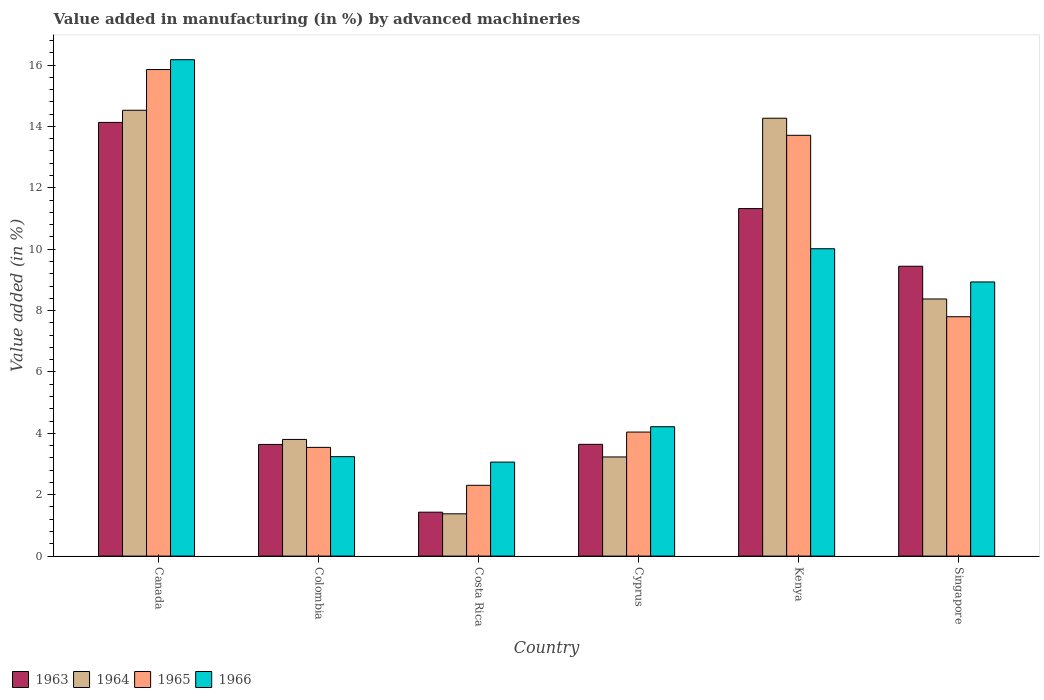How many different coloured bars are there?
Your answer should be very brief. 4. How many groups of bars are there?
Offer a very short reply. 6. Are the number of bars on each tick of the X-axis equal?
Ensure brevity in your answer.  Yes. How many bars are there on the 1st tick from the right?
Provide a short and direct response. 4. In how many cases, is the number of bars for a given country not equal to the number of legend labels?
Offer a very short reply. 0. What is the percentage of value added in manufacturing by advanced machineries in 1966 in Cyprus?
Make the answer very short. 4.22. Across all countries, what is the maximum percentage of value added in manufacturing by advanced machineries in 1966?
Offer a terse response. 16.17. Across all countries, what is the minimum percentage of value added in manufacturing by advanced machineries in 1965?
Keep it short and to the point. 2.31. What is the total percentage of value added in manufacturing by advanced machineries in 1966 in the graph?
Your response must be concise. 45.64. What is the difference between the percentage of value added in manufacturing by advanced machineries in 1966 in Canada and that in Kenya?
Offer a very short reply. 6.16. What is the difference between the percentage of value added in manufacturing by advanced machineries in 1964 in Cyprus and the percentage of value added in manufacturing by advanced machineries in 1965 in Costa Rica?
Give a very brief answer. 0.92. What is the average percentage of value added in manufacturing by advanced machineries in 1964 per country?
Offer a terse response. 7.6. What is the difference between the percentage of value added in manufacturing by advanced machineries of/in 1964 and percentage of value added in manufacturing by advanced machineries of/in 1963 in Kenya?
Provide a succinct answer. 2.94. In how many countries, is the percentage of value added in manufacturing by advanced machineries in 1965 greater than 14.4 %?
Keep it short and to the point. 1. What is the ratio of the percentage of value added in manufacturing by advanced machineries in 1966 in Kenya to that in Singapore?
Offer a very short reply. 1.12. Is the difference between the percentage of value added in manufacturing by advanced machineries in 1964 in Canada and Colombia greater than the difference between the percentage of value added in manufacturing by advanced machineries in 1963 in Canada and Colombia?
Your answer should be compact. Yes. What is the difference between the highest and the second highest percentage of value added in manufacturing by advanced machineries in 1965?
Make the answer very short. -5.91. What is the difference between the highest and the lowest percentage of value added in manufacturing by advanced machineries in 1966?
Ensure brevity in your answer.  13.11. In how many countries, is the percentage of value added in manufacturing by advanced machineries in 1964 greater than the average percentage of value added in manufacturing by advanced machineries in 1964 taken over all countries?
Give a very brief answer. 3. Is the sum of the percentage of value added in manufacturing by advanced machineries in 1966 in Canada and Costa Rica greater than the maximum percentage of value added in manufacturing by advanced machineries in 1963 across all countries?
Give a very brief answer. Yes. What does the 1st bar from the left in Singapore represents?
Provide a succinct answer. 1963. What does the 1st bar from the right in Kenya represents?
Your answer should be very brief. 1966. How many bars are there?
Offer a terse response. 24. Are the values on the major ticks of Y-axis written in scientific E-notation?
Give a very brief answer. No. Does the graph contain any zero values?
Your answer should be very brief. No. How are the legend labels stacked?
Provide a succinct answer. Horizontal. What is the title of the graph?
Make the answer very short. Value added in manufacturing (in %) by advanced machineries. What is the label or title of the X-axis?
Offer a very short reply. Country. What is the label or title of the Y-axis?
Your answer should be compact. Value added (in %). What is the Value added (in %) in 1963 in Canada?
Offer a very short reply. 14.13. What is the Value added (in %) in 1964 in Canada?
Offer a very short reply. 14.53. What is the Value added (in %) in 1965 in Canada?
Make the answer very short. 15.85. What is the Value added (in %) of 1966 in Canada?
Make the answer very short. 16.17. What is the Value added (in %) of 1963 in Colombia?
Your answer should be compact. 3.64. What is the Value added (in %) of 1964 in Colombia?
Keep it short and to the point. 3.8. What is the Value added (in %) in 1965 in Colombia?
Provide a succinct answer. 3.54. What is the Value added (in %) in 1966 in Colombia?
Give a very brief answer. 3.24. What is the Value added (in %) of 1963 in Costa Rica?
Your answer should be very brief. 1.43. What is the Value added (in %) in 1964 in Costa Rica?
Ensure brevity in your answer.  1.38. What is the Value added (in %) in 1965 in Costa Rica?
Offer a very short reply. 2.31. What is the Value added (in %) of 1966 in Costa Rica?
Your answer should be very brief. 3.06. What is the Value added (in %) of 1963 in Cyprus?
Provide a short and direct response. 3.64. What is the Value added (in %) of 1964 in Cyprus?
Keep it short and to the point. 3.23. What is the Value added (in %) in 1965 in Cyprus?
Your response must be concise. 4.04. What is the Value added (in %) in 1966 in Cyprus?
Give a very brief answer. 4.22. What is the Value added (in %) in 1963 in Kenya?
Provide a succinct answer. 11.32. What is the Value added (in %) in 1964 in Kenya?
Your answer should be compact. 14.27. What is the Value added (in %) of 1965 in Kenya?
Provide a short and direct response. 13.71. What is the Value added (in %) of 1966 in Kenya?
Your answer should be very brief. 10.01. What is the Value added (in %) of 1963 in Singapore?
Ensure brevity in your answer.  9.44. What is the Value added (in %) in 1964 in Singapore?
Your response must be concise. 8.38. What is the Value added (in %) of 1965 in Singapore?
Your response must be concise. 7.8. What is the Value added (in %) of 1966 in Singapore?
Ensure brevity in your answer.  8.93. Across all countries, what is the maximum Value added (in %) in 1963?
Ensure brevity in your answer.  14.13. Across all countries, what is the maximum Value added (in %) of 1964?
Give a very brief answer. 14.53. Across all countries, what is the maximum Value added (in %) in 1965?
Make the answer very short. 15.85. Across all countries, what is the maximum Value added (in %) of 1966?
Offer a very short reply. 16.17. Across all countries, what is the minimum Value added (in %) of 1963?
Provide a succinct answer. 1.43. Across all countries, what is the minimum Value added (in %) in 1964?
Provide a short and direct response. 1.38. Across all countries, what is the minimum Value added (in %) of 1965?
Give a very brief answer. 2.31. Across all countries, what is the minimum Value added (in %) in 1966?
Your response must be concise. 3.06. What is the total Value added (in %) of 1963 in the graph?
Keep it short and to the point. 43.61. What is the total Value added (in %) in 1964 in the graph?
Provide a succinct answer. 45.58. What is the total Value added (in %) of 1965 in the graph?
Provide a short and direct response. 47.25. What is the total Value added (in %) of 1966 in the graph?
Make the answer very short. 45.64. What is the difference between the Value added (in %) in 1963 in Canada and that in Colombia?
Offer a very short reply. 10.49. What is the difference between the Value added (in %) in 1964 in Canada and that in Colombia?
Offer a very short reply. 10.72. What is the difference between the Value added (in %) in 1965 in Canada and that in Colombia?
Provide a short and direct response. 12.31. What is the difference between the Value added (in %) of 1966 in Canada and that in Colombia?
Your response must be concise. 12.93. What is the difference between the Value added (in %) in 1963 in Canada and that in Costa Rica?
Give a very brief answer. 12.7. What is the difference between the Value added (in %) of 1964 in Canada and that in Costa Rica?
Provide a succinct answer. 13.15. What is the difference between the Value added (in %) in 1965 in Canada and that in Costa Rica?
Provide a short and direct response. 13.55. What is the difference between the Value added (in %) of 1966 in Canada and that in Costa Rica?
Offer a terse response. 13.11. What is the difference between the Value added (in %) in 1963 in Canada and that in Cyprus?
Give a very brief answer. 10.49. What is the difference between the Value added (in %) of 1964 in Canada and that in Cyprus?
Make the answer very short. 11.3. What is the difference between the Value added (in %) of 1965 in Canada and that in Cyprus?
Offer a terse response. 11.81. What is the difference between the Value added (in %) in 1966 in Canada and that in Cyprus?
Keep it short and to the point. 11.96. What is the difference between the Value added (in %) of 1963 in Canada and that in Kenya?
Offer a terse response. 2.81. What is the difference between the Value added (in %) of 1964 in Canada and that in Kenya?
Make the answer very short. 0.26. What is the difference between the Value added (in %) in 1965 in Canada and that in Kenya?
Offer a very short reply. 2.14. What is the difference between the Value added (in %) of 1966 in Canada and that in Kenya?
Provide a short and direct response. 6.16. What is the difference between the Value added (in %) of 1963 in Canada and that in Singapore?
Your response must be concise. 4.69. What is the difference between the Value added (in %) in 1964 in Canada and that in Singapore?
Ensure brevity in your answer.  6.15. What is the difference between the Value added (in %) in 1965 in Canada and that in Singapore?
Give a very brief answer. 8.05. What is the difference between the Value added (in %) in 1966 in Canada and that in Singapore?
Offer a terse response. 7.24. What is the difference between the Value added (in %) of 1963 in Colombia and that in Costa Rica?
Ensure brevity in your answer.  2.21. What is the difference between the Value added (in %) of 1964 in Colombia and that in Costa Rica?
Give a very brief answer. 2.42. What is the difference between the Value added (in %) of 1965 in Colombia and that in Costa Rica?
Offer a terse response. 1.24. What is the difference between the Value added (in %) of 1966 in Colombia and that in Costa Rica?
Your answer should be compact. 0.18. What is the difference between the Value added (in %) of 1963 in Colombia and that in Cyprus?
Offer a terse response. -0. What is the difference between the Value added (in %) in 1964 in Colombia and that in Cyprus?
Offer a very short reply. 0.57. What is the difference between the Value added (in %) of 1965 in Colombia and that in Cyprus?
Your answer should be very brief. -0.5. What is the difference between the Value added (in %) of 1966 in Colombia and that in Cyprus?
Keep it short and to the point. -0.97. What is the difference between the Value added (in %) in 1963 in Colombia and that in Kenya?
Your answer should be very brief. -7.69. What is the difference between the Value added (in %) in 1964 in Colombia and that in Kenya?
Keep it short and to the point. -10.47. What is the difference between the Value added (in %) in 1965 in Colombia and that in Kenya?
Your response must be concise. -10.17. What is the difference between the Value added (in %) in 1966 in Colombia and that in Kenya?
Provide a succinct answer. -6.77. What is the difference between the Value added (in %) of 1963 in Colombia and that in Singapore?
Make the answer very short. -5.81. What is the difference between the Value added (in %) in 1964 in Colombia and that in Singapore?
Your answer should be compact. -4.58. What is the difference between the Value added (in %) in 1965 in Colombia and that in Singapore?
Offer a terse response. -4.26. What is the difference between the Value added (in %) of 1966 in Colombia and that in Singapore?
Provide a short and direct response. -5.69. What is the difference between the Value added (in %) in 1963 in Costa Rica and that in Cyprus?
Your answer should be very brief. -2.21. What is the difference between the Value added (in %) of 1964 in Costa Rica and that in Cyprus?
Provide a succinct answer. -1.85. What is the difference between the Value added (in %) in 1965 in Costa Rica and that in Cyprus?
Your answer should be compact. -1.73. What is the difference between the Value added (in %) in 1966 in Costa Rica and that in Cyprus?
Give a very brief answer. -1.15. What is the difference between the Value added (in %) of 1963 in Costa Rica and that in Kenya?
Offer a very short reply. -9.89. What is the difference between the Value added (in %) of 1964 in Costa Rica and that in Kenya?
Give a very brief answer. -12.89. What is the difference between the Value added (in %) in 1965 in Costa Rica and that in Kenya?
Provide a succinct answer. -11.4. What is the difference between the Value added (in %) of 1966 in Costa Rica and that in Kenya?
Offer a very short reply. -6.95. What is the difference between the Value added (in %) in 1963 in Costa Rica and that in Singapore?
Offer a very short reply. -8.01. What is the difference between the Value added (in %) of 1964 in Costa Rica and that in Singapore?
Give a very brief answer. -7. What is the difference between the Value added (in %) in 1965 in Costa Rica and that in Singapore?
Your answer should be compact. -5.49. What is the difference between the Value added (in %) of 1966 in Costa Rica and that in Singapore?
Provide a succinct answer. -5.87. What is the difference between the Value added (in %) of 1963 in Cyprus and that in Kenya?
Your response must be concise. -7.68. What is the difference between the Value added (in %) in 1964 in Cyprus and that in Kenya?
Your answer should be compact. -11.04. What is the difference between the Value added (in %) in 1965 in Cyprus and that in Kenya?
Ensure brevity in your answer.  -9.67. What is the difference between the Value added (in %) in 1966 in Cyprus and that in Kenya?
Give a very brief answer. -5.8. What is the difference between the Value added (in %) of 1963 in Cyprus and that in Singapore?
Keep it short and to the point. -5.8. What is the difference between the Value added (in %) in 1964 in Cyprus and that in Singapore?
Your answer should be very brief. -5.15. What is the difference between the Value added (in %) of 1965 in Cyprus and that in Singapore?
Offer a very short reply. -3.76. What is the difference between the Value added (in %) in 1966 in Cyprus and that in Singapore?
Offer a very short reply. -4.72. What is the difference between the Value added (in %) of 1963 in Kenya and that in Singapore?
Give a very brief answer. 1.88. What is the difference between the Value added (in %) in 1964 in Kenya and that in Singapore?
Provide a succinct answer. 5.89. What is the difference between the Value added (in %) of 1965 in Kenya and that in Singapore?
Your response must be concise. 5.91. What is the difference between the Value added (in %) of 1966 in Kenya and that in Singapore?
Give a very brief answer. 1.08. What is the difference between the Value added (in %) of 1963 in Canada and the Value added (in %) of 1964 in Colombia?
Your answer should be very brief. 10.33. What is the difference between the Value added (in %) of 1963 in Canada and the Value added (in %) of 1965 in Colombia?
Provide a short and direct response. 10.59. What is the difference between the Value added (in %) of 1963 in Canada and the Value added (in %) of 1966 in Colombia?
Provide a succinct answer. 10.89. What is the difference between the Value added (in %) in 1964 in Canada and the Value added (in %) in 1965 in Colombia?
Keep it short and to the point. 10.98. What is the difference between the Value added (in %) of 1964 in Canada and the Value added (in %) of 1966 in Colombia?
Provide a succinct answer. 11.29. What is the difference between the Value added (in %) of 1965 in Canada and the Value added (in %) of 1966 in Colombia?
Keep it short and to the point. 12.61. What is the difference between the Value added (in %) in 1963 in Canada and the Value added (in %) in 1964 in Costa Rica?
Provide a succinct answer. 12.75. What is the difference between the Value added (in %) in 1963 in Canada and the Value added (in %) in 1965 in Costa Rica?
Offer a terse response. 11.82. What is the difference between the Value added (in %) of 1963 in Canada and the Value added (in %) of 1966 in Costa Rica?
Provide a short and direct response. 11.07. What is the difference between the Value added (in %) of 1964 in Canada and the Value added (in %) of 1965 in Costa Rica?
Your answer should be compact. 12.22. What is the difference between the Value added (in %) in 1964 in Canada and the Value added (in %) in 1966 in Costa Rica?
Provide a short and direct response. 11.46. What is the difference between the Value added (in %) of 1965 in Canada and the Value added (in %) of 1966 in Costa Rica?
Your answer should be compact. 12.79. What is the difference between the Value added (in %) of 1963 in Canada and the Value added (in %) of 1964 in Cyprus?
Offer a very short reply. 10.9. What is the difference between the Value added (in %) of 1963 in Canada and the Value added (in %) of 1965 in Cyprus?
Your answer should be very brief. 10.09. What is the difference between the Value added (in %) of 1963 in Canada and the Value added (in %) of 1966 in Cyprus?
Your answer should be compact. 9.92. What is the difference between the Value added (in %) of 1964 in Canada and the Value added (in %) of 1965 in Cyprus?
Your response must be concise. 10.49. What is the difference between the Value added (in %) of 1964 in Canada and the Value added (in %) of 1966 in Cyprus?
Your answer should be compact. 10.31. What is the difference between the Value added (in %) of 1965 in Canada and the Value added (in %) of 1966 in Cyprus?
Your answer should be compact. 11.64. What is the difference between the Value added (in %) in 1963 in Canada and the Value added (in %) in 1964 in Kenya?
Keep it short and to the point. -0.14. What is the difference between the Value added (in %) in 1963 in Canada and the Value added (in %) in 1965 in Kenya?
Provide a short and direct response. 0.42. What is the difference between the Value added (in %) of 1963 in Canada and the Value added (in %) of 1966 in Kenya?
Keep it short and to the point. 4.12. What is the difference between the Value added (in %) of 1964 in Canada and the Value added (in %) of 1965 in Kenya?
Ensure brevity in your answer.  0.82. What is the difference between the Value added (in %) in 1964 in Canada and the Value added (in %) in 1966 in Kenya?
Your answer should be compact. 4.51. What is the difference between the Value added (in %) in 1965 in Canada and the Value added (in %) in 1966 in Kenya?
Provide a short and direct response. 5.84. What is the difference between the Value added (in %) in 1963 in Canada and the Value added (in %) in 1964 in Singapore?
Provide a succinct answer. 5.75. What is the difference between the Value added (in %) of 1963 in Canada and the Value added (in %) of 1965 in Singapore?
Give a very brief answer. 6.33. What is the difference between the Value added (in %) in 1963 in Canada and the Value added (in %) in 1966 in Singapore?
Ensure brevity in your answer.  5.2. What is the difference between the Value added (in %) in 1964 in Canada and the Value added (in %) in 1965 in Singapore?
Make the answer very short. 6.73. What is the difference between the Value added (in %) in 1964 in Canada and the Value added (in %) in 1966 in Singapore?
Your answer should be compact. 5.59. What is the difference between the Value added (in %) in 1965 in Canada and the Value added (in %) in 1966 in Singapore?
Provide a short and direct response. 6.92. What is the difference between the Value added (in %) of 1963 in Colombia and the Value added (in %) of 1964 in Costa Rica?
Make the answer very short. 2.26. What is the difference between the Value added (in %) in 1963 in Colombia and the Value added (in %) in 1965 in Costa Rica?
Keep it short and to the point. 1.33. What is the difference between the Value added (in %) in 1963 in Colombia and the Value added (in %) in 1966 in Costa Rica?
Your answer should be compact. 0.57. What is the difference between the Value added (in %) of 1964 in Colombia and the Value added (in %) of 1965 in Costa Rica?
Give a very brief answer. 1.49. What is the difference between the Value added (in %) in 1964 in Colombia and the Value added (in %) in 1966 in Costa Rica?
Keep it short and to the point. 0.74. What is the difference between the Value added (in %) in 1965 in Colombia and the Value added (in %) in 1966 in Costa Rica?
Offer a terse response. 0.48. What is the difference between the Value added (in %) in 1963 in Colombia and the Value added (in %) in 1964 in Cyprus?
Make the answer very short. 0.41. What is the difference between the Value added (in %) in 1963 in Colombia and the Value added (in %) in 1965 in Cyprus?
Provide a succinct answer. -0.4. What is the difference between the Value added (in %) of 1963 in Colombia and the Value added (in %) of 1966 in Cyprus?
Give a very brief answer. -0.58. What is the difference between the Value added (in %) in 1964 in Colombia and the Value added (in %) in 1965 in Cyprus?
Offer a terse response. -0.24. What is the difference between the Value added (in %) in 1964 in Colombia and the Value added (in %) in 1966 in Cyprus?
Your response must be concise. -0.41. What is the difference between the Value added (in %) in 1965 in Colombia and the Value added (in %) in 1966 in Cyprus?
Your response must be concise. -0.67. What is the difference between the Value added (in %) of 1963 in Colombia and the Value added (in %) of 1964 in Kenya?
Provide a succinct answer. -10.63. What is the difference between the Value added (in %) in 1963 in Colombia and the Value added (in %) in 1965 in Kenya?
Provide a short and direct response. -10.07. What is the difference between the Value added (in %) of 1963 in Colombia and the Value added (in %) of 1966 in Kenya?
Ensure brevity in your answer.  -6.38. What is the difference between the Value added (in %) in 1964 in Colombia and the Value added (in %) in 1965 in Kenya?
Provide a succinct answer. -9.91. What is the difference between the Value added (in %) in 1964 in Colombia and the Value added (in %) in 1966 in Kenya?
Offer a very short reply. -6.21. What is the difference between the Value added (in %) of 1965 in Colombia and the Value added (in %) of 1966 in Kenya?
Your answer should be very brief. -6.47. What is the difference between the Value added (in %) in 1963 in Colombia and the Value added (in %) in 1964 in Singapore?
Your answer should be very brief. -4.74. What is the difference between the Value added (in %) of 1963 in Colombia and the Value added (in %) of 1965 in Singapore?
Your answer should be compact. -4.16. What is the difference between the Value added (in %) in 1963 in Colombia and the Value added (in %) in 1966 in Singapore?
Make the answer very short. -5.29. What is the difference between the Value added (in %) in 1964 in Colombia and the Value added (in %) in 1965 in Singapore?
Offer a very short reply. -4. What is the difference between the Value added (in %) of 1964 in Colombia and the Value added (in %) of 1966 in Singapore?
Provide a short and direct response. -5.13. What is the difference between the Value added (in %) of 1965 in Colombia and the Value added (in %) of 1966 in Singapore?
Make the answer very short. -5.39. What is the difference between the Value added (in %) in 1963 in Costa Rica and the Value added (in %) in 1964 in Cyprus?
Provide a short and direct response. -1.8. What is the difference between the Value added (in %) in 1963 in Costa Rica and the Value added (in %) in 1965 in Cyprus?
Provide a succinct answer. -2.61. What is the difference between the Value added (in %) in 1963 in Costa Rica and the Value added (in %) in 1966 in Cyprus?
Keep it short and to the point. -2.78. What is the difference between the Value added (in %) of 1964 in Costa Rica and the Value added (in %) of 1965 in Cyprus?
Give a very brief answer. -2.66. What is the difference between the Value added (in %) of 1964 in Costa Rica and the Value added (in %) of 1966 in Cyprus?
Provide a short and direct response. -2.84. What is the difference between the Value added (in %) of 1965 in Costa Rica and the Value added (in %) of 1966 in Cyprus?
Keep it short and to the point. -1.91. What is the difference between the Value added (in %) of 1963 in Costa Rica and the Value added (in %) of 1964 in Kenya?
Provide a short and direct response. -12.84. What is the difference between the Value added (in %) in 1963 in Costa Rica and the Value added (in %) in 1965 in Kenya?
Give a very brief answer. -12.28. What is the difference between the Value added (in %) of 1963 in Costa Rica and the Value added (in %) of 1966 in Kenya?
Make the answer very short. -8.58. What is the difference between the Value added (in %) of 1964 in Costa Rica and the Value added (in %) of 1965 in Kenya?
Ensure brevity in your answer.  -12.33. What is the difference between the Value added (in %) in 1964 in Costa Rica and the Value added (in %) in 1966 in Kenya?
Ensure brevity in your answer.  -8.64. What is the difference between the Value added (in %) in 1965 in Costa Rica and the Value added (in %) in 1966 in Kenya?
Ensure brevity in your answer.  -7.71. What is the difference between the Value added (in %) of 1963 in Costa Rica and the Value added (in %) of 1964 in Singapore?
Make the answer very short. -6.95. What is the difference between the Value added (in %) of 1963 in Costa Rica and the Value added (in %) of 1965 in Singapore?
Give a very brief answer. -6.37. What is the difference between the Value added (in %) of 1963 in Costa Rica and the Value added (in %) of 1966 in Singapore?
Keep it short and to the point. -7.5. What is the difference between the Value added (in %) of 1964 in Costa Rica and the Value added (in %) of 1965 in Singapore?
Provide a succinct answer. -6.42. What is the difference between the Value added (in %) of 1964 in Costa Rica and the Value added (in %) of 1966 in Singapore?
Offer a terse response. -7.55. What is the difference between the Value added (in %) of 1965 in Costa Rica and the Value added (in %) of 1966 in Singapore?
Your answer should be compact. -6.63. What is the difference between the Value added (in %) of 1963 in Cyprus and the Value added (in %) of 1964 in Kenya?
Offer a terse response. -10.63. What is the difference between the Value added (in %) in 1963 in Cyprus and the Value added (in %) in 1965 in Kenya?
Provide a short and direct response. -10.07. What is the difference between the Value added (in %) in 1963 in Cyprus and the Value added (in %) in 1966 in Kenya?
Your answer should be compact. -6.37. What is the difference between the Value added (in %) of 1964 in Cyprus and the Value added (in %) of 1965 in Kenya?
Give a very brief answer. -10.48. What is the difference between the Value added (in %) in 1964 in Cyprus and the Value added (in %) in 1966 in Kenya?
Make the answer very short. -6.78. What is the difference between the Value added (in %) in 1965 in Cyprus and the Value added (in %) in 1966 in Kenya?
Make the answer very short. -5.97. What is the difference between the Value added (in %) in 1963 in Cyprus and the Value added (in %) in 1964 in Singapore?
Keep it short and to the point. -4.74. What is the difference between the Value added (in %) of 1963 in Cyprus and the Value added (in %) of 1965 in Singapore?
Ensure brevity in your answer.  -4.16. What is the difference between the Value added (in %) in 1963 in Cyprus and the Value added (in %) in 1966 in Singapore?
Give a very brief answer. -5.29. What is the difference between the Value added (in %) of 1964 in Cyprus and the Value added (in %) of 1965 in Singapore?
Offer a terse response. -4.57. What is the difference between the Value added (in %) of 1964 in Cyprus and the Value added (in %) of 1966 in Singapore?
Offer a very short reply. -5.7. What is the difference between the Value added (in %) of 1965 in Cyprus and the Value added (in %) of 1966 in Singapore?
Your answer should be very brief. -4.89. What is the difference between the Value added (in %) of 1963 in Kenya and the Value added (in %) of 1964 in Singapore?
Your answer should be compact. 2.95. What is the difference between the Value added (in %) of 1963 in Kenya and the Value added (in %) of 1965 in Singapore?
Your answer should be very brief. 3.52. What is the difference between the Value added (in %) of 1963 in Kenya and the Value added (in %) of 1966 in Singapore?
Ensure brevity in your answer.  2.39. What is the difference between the Value added (in %) of 1964 in Kenya and the Value added (in %) of 1965 in Singapore?
Your answer should be very brief. 6.47. What is the difference between the Value added (in %) of 1964 in Kenya and the Value added (in %) of 1966 in Singapore?
Your answer should be very brief. 5.33. What is the difference between the Value added (in %) in 1965 in Kenya and the Value added (in %) in 1966 in Singapore?
Ensure brevity in your answer.  4.78. What is the average Value added (in %) of 1963 per country?
Make the answer very short. 7.27. What is the average Value added (in %) in 1964 per country?
Give a very brief answer. 7.6. What is the average Value added (in %) in 1965 per country?
Your answer should be very brief. 7.88. What is the average Value added (in %) in 1966 per country?
Give a very brief answer. 7.61. What is the difference between the Value added (in %) of 1963 and Value added (in %) of 1964 in Canada?
Offer a very short reply. -0.4. What is the difference between the Value added (in %) of 1963 and Value added (in %) of 1965 in Canada?
Your response must be concise. -1.72. What is the difference between the Value added (in %) of 1963 and Value added (in %) of 1966 in Canada?
Your response must be concise. -2.04. What is the difference between the Value added (in %) of 1964 and Value added (in %) of 1965 in Canada?
Ensure brevity in your answer.  -1.33. What is the difference between the Value added (in %) in 1964 and Value added (in %) in 1966 in Canada?
Offer a terse response. -1.65. What is the difference between the Value added (in %) in 1965 and Value added (in %) in 1966 in Canada?
Your answer should be very brief. -0.32. What is the difference between the Value added (in %) of 1963 and Value added (in %) of 1964 in Colombia?
Offer a very short reply. -0.16. What is the difference between the Value added (in %) of 1963 and Value added (in %) of 1965 in Colombia?
Your answer should be compact. 0.1. What is the difference between the Value added (in %) of 1963 and Value added (in %) of 1966 in Colombia?
Keep it short and to the point. 0.4. What is the difference between the Value added (in %) of 1964 and Value added (in %) of 1965 in Colombia?
Your answer should be very brief. 0.26. What is the difference between the Value added (in %) of 1964 and Value added (in %) of 1966 in Colombia?
Offer a terse response. 0.56. What is the difference between the Value added (in %) in 1965 and Value added (in %) in 1966 in Colombia?
Your answer should be compact. 0.3. What is the difference between the Value added (in %) in 1963 and Value added (in %) in 1964 in Costa Rica?
Make the answer very short. 0.05. What is the difference between the Value added (in %) of 1963 and Value added (in %) of 1965 in Costa Rica?
Ensure brevity in your answer.  -0.88. What is the difference between the Value added (in %) of 1963 and Value added (in %) of 1966 in Costa Rica?
Your response must be concise. -1.63. What is the difference between the Value added (in %) in 1964 and Value added (in %) in 1965 in Costa Rica?
Your answer should be compact. -0.93. What is the difference between the Value added (in %) in 1964 and Value added (in %) in 1966 in Costa Rica?
Your answer should be compact. -1.69. What is the difference between the Value added (in %) in 1965 and Value added (in %) in 1966 in Costa Rica?
Your answer should be very brief. -0.76. What is the difference between the Value added (in %) of 1963 and Value added (in %) of 1964 in Cyprus?
Give a very brief answer. 0.41. What is the difference between the Value added (in %) of 1963 and Value added (in %) of 1965 in Cyprus?
Your response must be concise. -0.4. What is the difference between the Value added (in %) in 1963 and Value added (in %) in 1966 in Cyprus?
Make the answer very short. -0.57. What is the difference between the Value added (in %) in 1964 and Value added (in %) in 1965 in Cyprus?
Ensure brevity in your answer.  -0.81. What is the difference between the Value added (in %) of 1964 and Value added (in %) of 1966 in Cyprus?
Your answer should be compact. -0.98. What is the difference between the Value added (in %) of 1965 and Value added (in %) of 1966 in Cyprus?
Keep it short and to the point. -0.17. What is the difference between the Value added (in %) in 1963 and Value added (in %) in 1964 in Kenya?
Your answer should be very brief. -2.94. What is the difference between the Value added (in %) of 1963 and Value added (in %) of 1965 in Kenya?
Provide a succinct answer. -2.39. What is the difference between the Value added (in %) of 1963 and Value added (in %) of 1966 in Kenya?
Offer a very short reply. 1.31. What is the difference between the Value added (in %) of 1964 and Value added (in %) of 1965 in Kenya?
Offer a very short reply. 0.56. What is the difference between the Value added (in %) of 1964 and Value added (in %) of 1966 in Kenya?
Keep it short and to the point. 4.25. What is the difference between the Value added (in %) of 1965 and Value added (in %) of 1966 in Kenya?
Ensure brevity in your answer.  3.7. What is the difference between the Value added (in %) of 1963 and Value added (in %) of 1964 in Singapore?
Make the answer very short. 1.07. What is the difference between the Value added (in %) of 1963 and Value added (in %) of 1965 in Singapore?
Offer a terse response. 1.64. What is the difference between the Value added (in %) in 1963 and Value added (in %) in 1966 in Singapore?
Make the answer very short. 0.51. What is the difference between the Value added (in %) of 1964 and Value added (in %) of 1965 in Singapore?
Make the answer very short. 0.58. What is the difference between the Value added (in %) of 1964 and Value added (in %) of 1966 in Singapore?
Provide a short and direct response. -0.55. What is the difference between the Value added (in %) in 1965 and Value added (in %) in 1966 in Singapore?
Provide a short and direct response. -1.13. What is the ratio of the Value added (in %) in 1963 in Canada to that in Colombia?
Ensure brevity in your answer.  3.88. What is the ratio of the Value added (in %) in 1964 in Canada to that in Colombia?
Ensure brevity in your answer.  3.82. What is the ratio of the Value added (in %) in 1965 in Canada to that in Colombia?
Provide a succinct answer. 4.48. What is the ratio of the Value added (in %) of 1966 in Canada to that in Colombia?
Offer a very short reply. 4.99. What is the ratio of the Value added (in %) of 1963 in Canada to that in Costa Rica?
Offer a very short reply. 9.87. What is the ratio of the Value added (in %) in 1964 in Canada to that in Costa Rica?
Your response must be concise. 10.54. What is the ratio of the Value added (in %) of 1965 in Canada to that in Costa Rica?
Keep it short and to the point. 6.87. What is the ratio of the Value added (in %) of 1966 in Canada to that in Costa Rica?
Offer a very short reply. 5.28. What is the ratio of the Value added (in %) in 1963 in Canada to that in Cyprus?
Your answer should be compact. 3.88. What is the ratio of the Value added (in %) in 1964 in Canada to that in Cyprus?
Make the answer very short. 4.5. What is the ratio of the Value added (in %) of 1965 in Canada to that in Cyprus?
Provide a short and direct response. 3.92. What is the ratio of the Value added (in %) in 1966 in Canada to that in Cyprus?
Your answer should be very brief. 3.84. What is the ratio of the Value added (in %) of 1963 in Canada to that in Kenya?
Keep it short and to the point. 1.25. What is the ratio of the Value added (in %) of 1964 in Canada to that in Kenya?
Your answer should be compact. 1.02. What is the ratio of the Value added (in %) in 1965 in Canada to that in Kenya?
Make the answer very short. 1.16. What is the ratio of the Value added (in %) of 1966 in Canada to that in Kenya?
Keep it short and to the point. 1.62. What is the ratio of the Value added (in %) of 1963 in Canada to that in Singapore?
Keep it short and to the point. 1.5. What is the ratio of the Value added (in %) of 1964 in Canada to that in Singapore?
Provide a succinct answer. 1.73. What is the ratio of the Value added (in %) in 1965 in Canada to that in Singapore?
Your answer should be very brief. 2.03. What is the ratio of the Value added (in %) of 1966 in Canada to that in Singapore?
Provide a succinct answer. 1.81. What is the ratio of the Value added (in %) in 1963 in Colombia to that in Costa Rica?
Keep it short and to the point. 2.54. What is the ratio of the Value added (in %) of 1964 in Colombia to that in Costa Rica?
Make the answer very short. 2.76. What is the ratio of the Value added (in %) of 1965 in Colombia to that in Costa Rica?
Your answer should be very brief. 1.54. What is the ratio of the Value added (in %) in 1966 in Colombia to that in Costa Rica?
Provide a succinct answer. 1.06. What is the ratio of the Value added (in %) in 1963 in Colombia to that in Cyprus?
Give a very brief answer. 1. What is the ratio of the Value added (in %) in 1964 in Colombia to that in Cyprus?
Offer a terse response. 1.18. What is the ratio of the Value added (in %) in 1965 in Colombia to that in Cyprus?
Ensure brevity in your answer.  0.88. What is the ratio of the Value added (in %) in 1966 in Colombia to that in Cyprus?
Give a very brief answer. 0.77. What is the ratio of the Value added (in %) in 1963 in Colombia to that in Kenya?
Provide a succinct answer. 0.32. What is the ratio of the Value added (in %) in 1964 in Colombia to that in Kenya?
Your response must be concise. 0.27. What is the ratio of the Value added (in %) of 1965 in Colombia to that in Kenya?
Your response must be concise. 0.26. What is the ratio of the Value added (in %) in 1966 in Colombia to that in Kenya?
Your answer should be very brief. 0.32. What is the ratio of the Value added (in %) of 1963 in Colombia to that in Singapore?
Offer a terse response. 0.39. What is the ratio of the Value added (in %) in 1964 in Colombia to that in Singapore?
Provide a short and direct response. 0.45. What is the ratio of the Value added (in %) in 1965 in Colombia to that in Singapore?
Provide a succinct answer. 0.45. What is the ratio of the Value added (in %) in 1966 in Colombia to that in Singapore?
Provide a short and direct response. 0.36. What is the ratio of the Value added (in %) of 1963 in Costa Rica to that in Cyprus?
Your response must be concise. 0.39. What is the ratio of the Value added (in %) of 1964 in Costa Rica to that in Cyprus?
Offer a terse response. 0.43. What is the ratio of the Value added (in %) of 1965 in Costa Rica to that in Cyprus?
Provide a succinct answer. 0.57. What is the ratio of the Value added (in %) of 1966 in Costa Rica to that in Cyprus?
Offer a very short reply. 0.73. What is the ratio of the Value added (in %) of 1963 in Costa Rica to that in Kenya?
Make the answer very short. 0.13. What is the ratio of the Value added (in %) of 1964 in Costa Rica to that in Kenya?
Keep it short and to the point. 0.1. What is the ratio of the Value added (in %) in 1965 in Costa Rica to that in Kenya?
Your response must be concise. 0.17. What is the ratio of the Value added (in %) of 1966 in Costa Rica to that in Kenya?
Give a very brief answer. 0.31. What is the ratio of the Value added (in %) in 1963 in Costa Rica to that in Singapore?
Your response must be concise. 0.15. What is the ratio of the Value added (in %) of 1964 in Costa Rica to that in Singapore?
Your answer should be compact. 0.16. What is the ratio of the Value added (in %) in 1965 in Costa Rica to that in Singapore?
Make the answer very short. 0.3. What is the ratio of the Value added (in %) of 1966 in Costa Rica to that in Singapore?
Offer a terse response. 0.34. What is the ratio of the Value added (in %) in 1963 in Cyprus to that in Kenya?
Your response must be concise. 0.32. What is the ratio of the Value added (in %) in 1964 in Cyprus to that in Kenya?
Your answer should be very brief. 0.23. What is the ratio of the Value added (in %) in 1965 in Cyprus to that in Kenya?
Keep it short and to the point. 0.29. What is the ratio of the Value added (in %) of 1966 in Cyprus to that in Kenya?
Keep it short and to the point. 0.42. What is the ratio of the Value added (in %) of 1963 in Cyprus to that in Singapore?
Offer a terse response. 0.39. What is the ratio of the Value added (in %) of 1964 in Cyprus to that in Singapore?
Provide a succinct answer. 0.39. What is the ratio of the Value added (in %) in 1965 in Cyprus to that in Singapore?
Your answer should be very brief. 0.52. What is the ratio of the Value added (in %) in 1966 in Cyprus to that in Singapore?
Make the answer very short. 0.47. What is the ratio of the Value added (in %) in 1963 in Kenya to that in Singapore?
Provide a succinct answer. 1.2. What is the ratio of the Value added (in %) of 1964 in Kenya to that in Singapore?
Ensure brevity in your answer.  1.7. What is the ratio of the Value added (in %) of 1965 in Kenya to that in Singapore?
Your answer should be compact. 1.76. What is the ratio of the Value added (in %) of 1966 in Kenya to that in Singapore?
Provide a short and direct response. 1.12. What is the difference between the highest and the second highest Value added (in %) in 1963?
Keep it short and to the point. 2.81. What is the difference between the highest and the second highest Value added (in %) of 1964?
Provide a succinct answer. 0.26. What is the difference between the highest and the second highest Value added (in %) in 1965?
Offer a terse response. 2.14. What is the difference between the highest and the second highest Value added (in %) of 1966?
Make the answer very short. 6.16. What is the difference between the highest and the lowest Value added (in %) of 1963?
Make the answer very short. 12.7. What is the difference between the highest and the lowest Value added (in %) of 1964?
Make the answer very short. 13.15. What is the difference between the highest and the lowest Value added (in %) in 1965?
Provide a succinct answer. 13.55. What is the difference between the highest and the lowest Value added (in %) of 1966?
Make the answer very short. 13.11. 